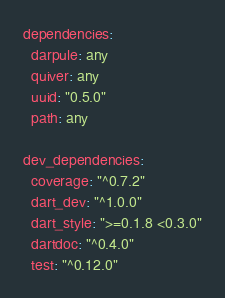Convert code to text. <code><loc_0><loc_0><loc_500><loc_500><_YAML_>dependencies:
  darpule: any
  quiver: any
  uuid: "0.5.0"
  path: any

dev_dependencies:
  coverage: "^0.7.2"
  dart_dev: "^1.0.0"
  dart_style: ">=0.1.8 <0.3.0"
  dartdoc: "^0.4.0"
  test: "^0.12.0"
</code> 